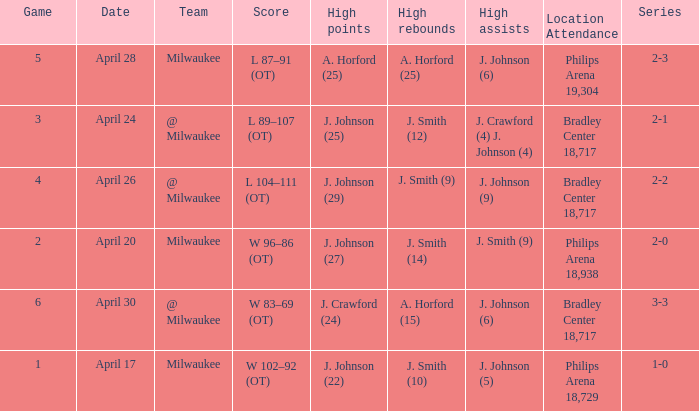What were the amount of rebounds in game 2? J. Smith (14). 